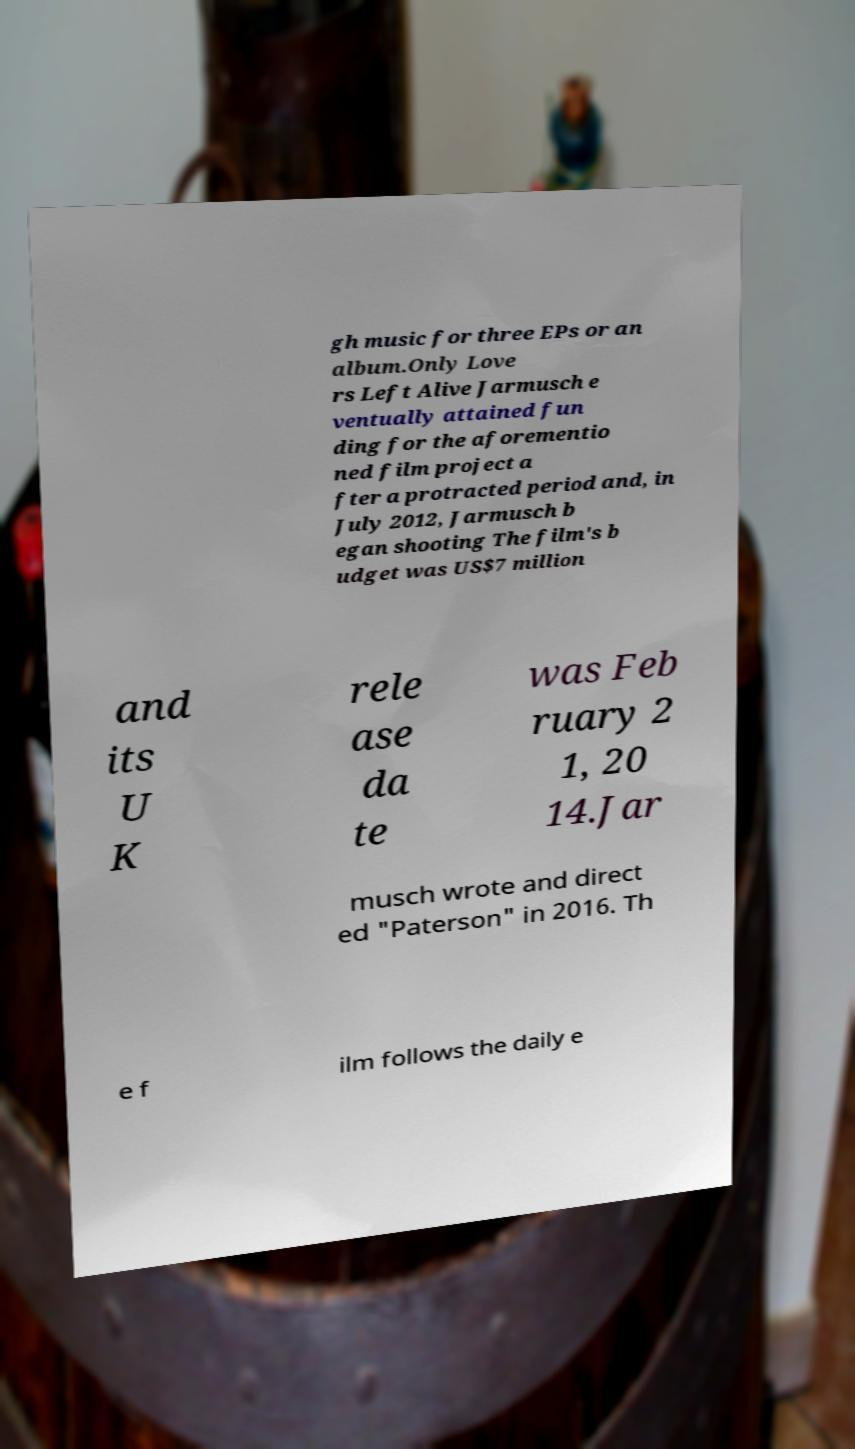Could you assist in decoding the text presented in this image and type it out clearly? gh music for three EPs or an album.Only Love rs Left Alive Jarmusch e ventually attained fun ding for the aforementio ned film project a fter a protracted period and, in July 2012, Jarmusch b egan shooting The film's b udget was US$7 million and its U K rele ase da te was Feb ruary 2 1, 20 14.Jar musch wrote and direct ed "Paterson" in 2016. Th e f ilm follows the daily e 